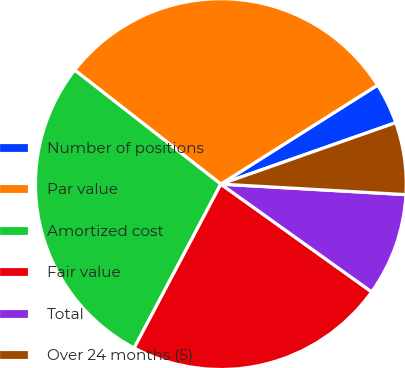Convert chart. <chart><loc_0><loc_0><loc_500><loc_500><pie_chart><fcel>Number of positions<fcel>Par value<fcel>Amortized cost<fcel>Fair value<fcel>Total<fcel>Over 24 months (5)<nl><fcel>3.59%<fcel>30.49%<fcel>27.8%<fcel>22.87%<fcel>8.97%<fcel>6.28%<nl></chart> 